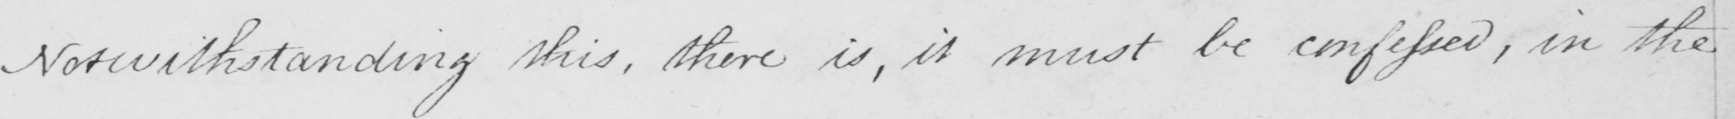Can you read and transcribe this handwriting? Notwithstanding this , there is , it must be confessed , in the 